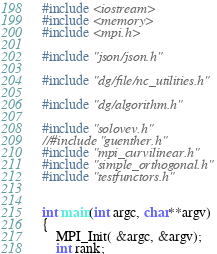Convert code to text. <code><loc_0><loc_0><loc_500><loc_500><_Cuda_>#include <iostream>
#include <memory>
#include <mpi.h>

#include "json/json.h"

#include "dg/file/nc_utilities.h"

#include "dg/algorithm.h"

#include "solovev.h"
//#include "guenther.h"
#include "mpi_curvilinear.h"
#include "simple_orthogonal.h"
#include "testfunctors.h"


int main(int argc, char**argv)
{
    MPI_Init( &argc, &argv);
    int rank;</code> 